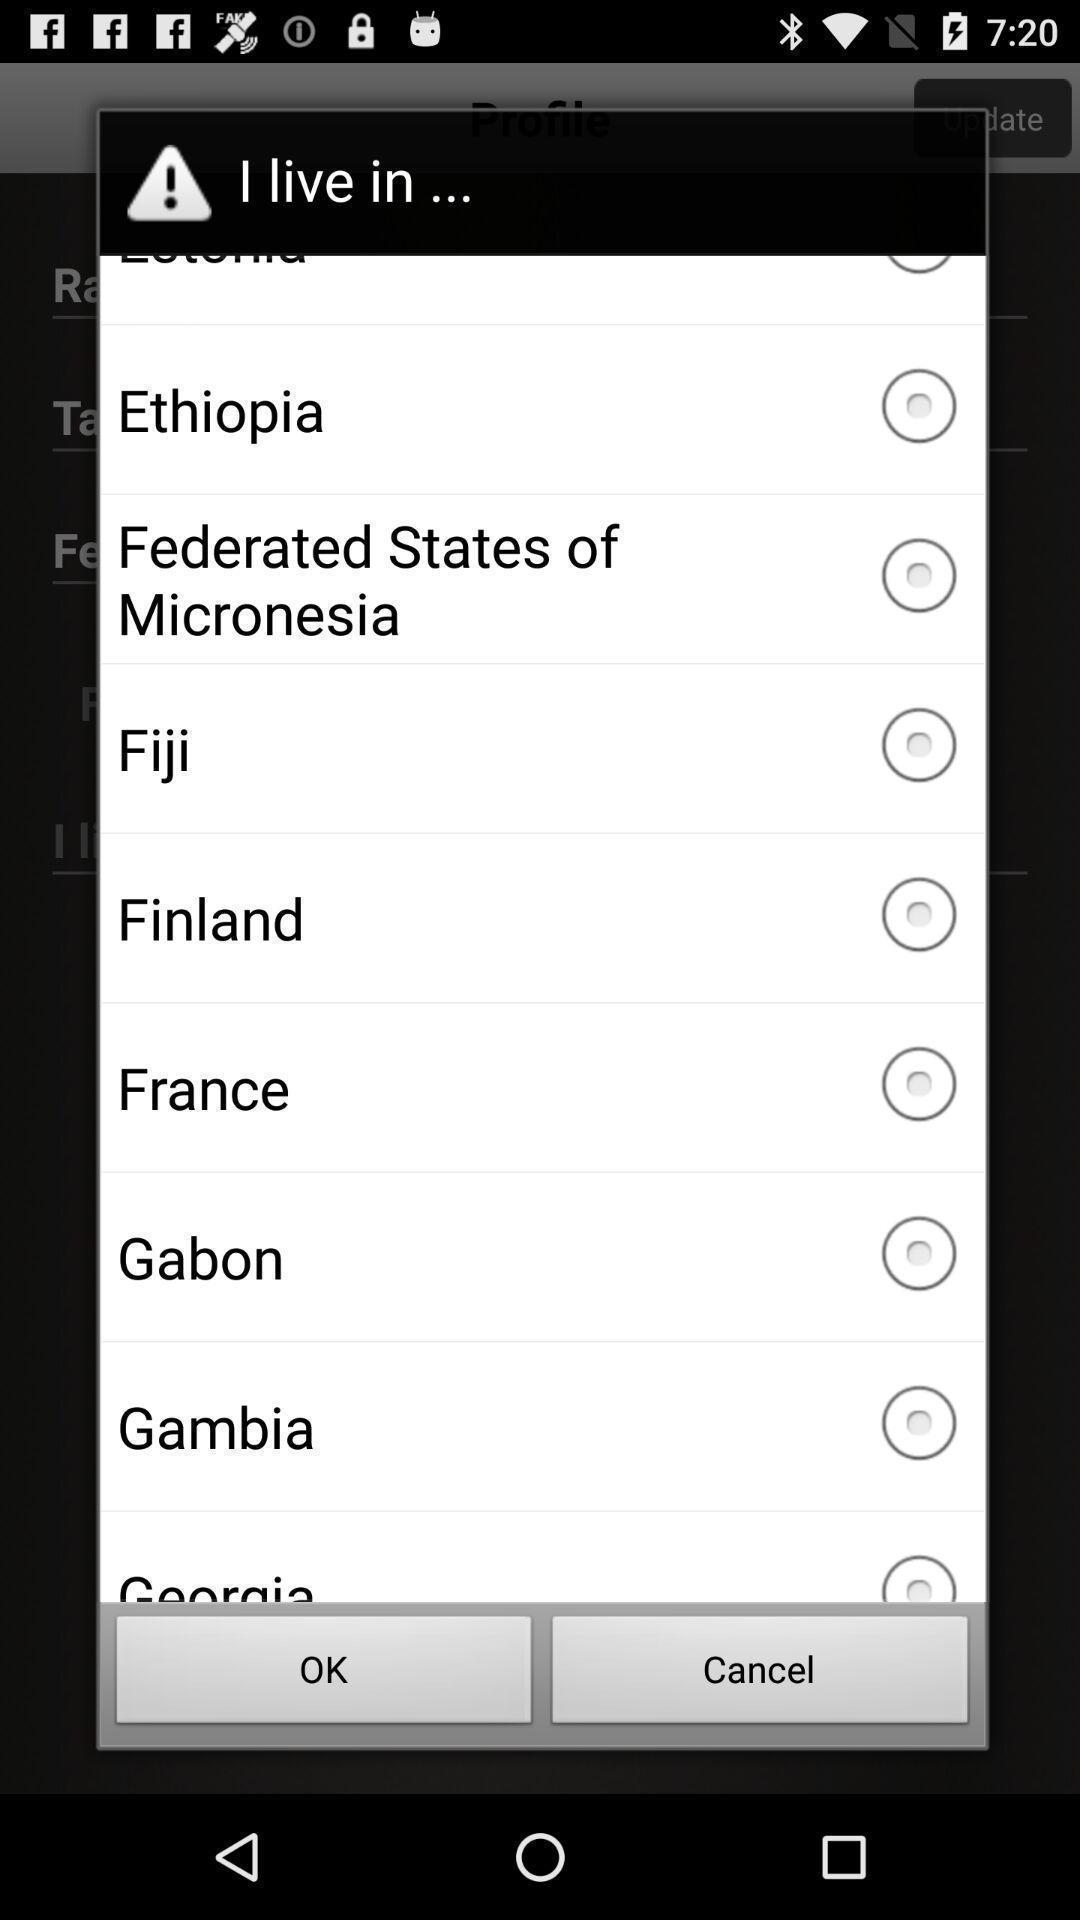Give me a summary of this screen capture. Pop-up showing to select location. 